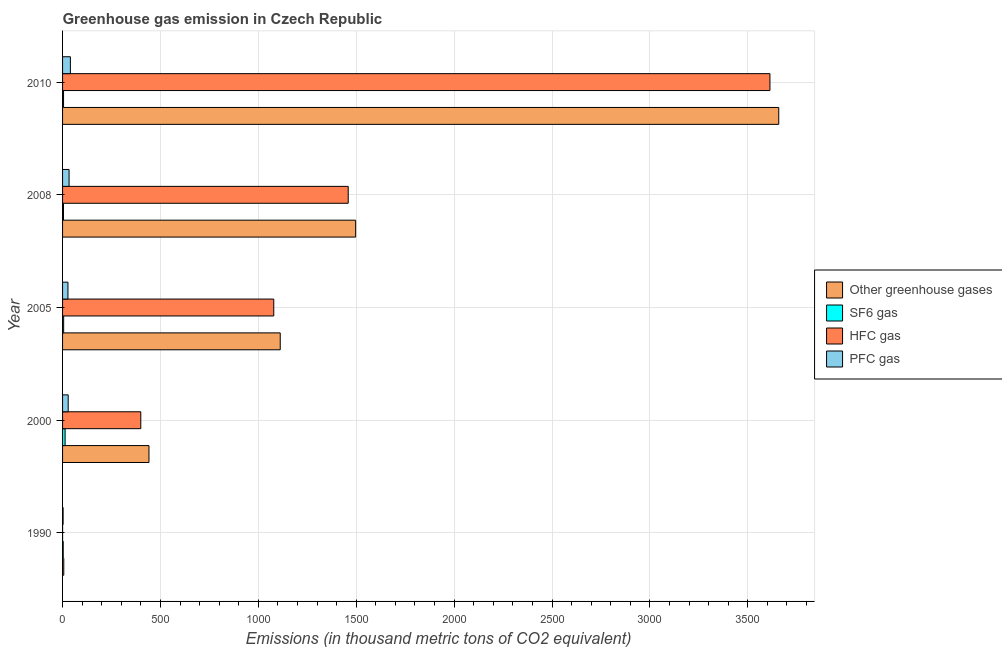How many different coloured bars are there?
Your response must be concise. 4. How many groups of bars are there?
Offer a terse response. 5. Are the number of bars per tick equal to the number of legend labels?
Ensure brevity in your answer.  Yes. How many bars are there on the 4th tick from the top?
Your answer should be compact. 4. What is the label of the 5th group of bars from the top?
Keep it short and to the point. 1990. In how many cases, is the number of bars for a given year not equal to the number of legend labels?
Provide a short and direct response. 0. What is the emission of hfc gas in 2005?
Provide a succinct answer. 1078.7. Across all years, what is the maximum emission of hfc gas?
Your answer should be very brief. 3613. Across all years, what is the minimum emission of pfc gas?
Your response must be concise. 2.8. In which year was the emission of sf6 gas maximum?
Ensure brevity in your answer.  2000. What is the total emission of hfc gas in the graph?
Provide a short and direct response. 6550.3. What is the difference between the emission of greenhouse gases in 2008 and that in 2010?
Ensure brevity in your answer.  -2161. What is the difference between the emission of greenhouse gases in 1990 and the emission of hfc gas in 2000?
Provide a short and direct response. -393.3. What is the average emission of hfc gas per year?
Offer a very short reply. 1310.06. In the year 2008, what is the difference between the emission of greenhouse gases and emission of sf6 gas?
Provide a succinct answer. 1492.3. What is the ratio of the emission of greenhouse gases in 1990 to that in 2005?
Offer a very short reply. 0.01. Is the emission of hfc gas in 1990 less than that in 2010?
Ensure brevity in your answer.  Yes. Is the difference between the emission of sf6 gas in 1990 and 2010 greater than the difference between the emission of pfc gas in 1990 and 2010?
Your answer should be very brief. Yes. What is the difference between the highest and the second highest emission of greenhouse gases?
Keep it short and to the point. 2161. What is the difference between the highest and the lowest emission of pfc gas?
Offer a terse response. 37.2. In how many years, is the emission of greenhouse gases greater than the average emission of greenhouse gases taken over all years?
Keep it short and to the point. 2. What does the 4th bar from the top in 1990 represents?
Offer a very short reply. Other greenhouse gases. What does the 4th bar from the bottom in 2005 represents?
Give a very brief answer. PFC gas. Is it the case that in every year, the sum of the emission of greenhouse gases and emission of sf6 gas is greater than the emission of hfc gas?
Provide a short and direct response. Yes. Are the values on the major ticks of X-axis written in scientific E-notation?
Your answer should be very brief. No. Does the graph contain any zero values?
Give a very brief answer. No. Does the graph contain grids?
Offer a very short reply. Yes. Where does the legend appear in the graph?
Keep it short and to the point. Center right. How many legend labels are there?
Provide a short and direct response. 4. What is the title of the graph?
Ensure brevity in your answer.  Greenhouse gas emission in Czech Republic. What is the label or title of the X-axis?
Offer a terse response. Emissions (in thousand metric tons of CO2 equivalent). What is the Emissions (in thousand metric tons of CO2 equivalent) of SF6 gas in 1990?
Ensure brevity in your answer.  3.3. What is the Emissions (in thousand metric tons of CO2 equivalent) of HFC gas in 1990?
Provide a succinct answer. 0.1. What is the Emissions (in thousand metric tons of CO2 equivalent) in PFC gas in 1990?
Provide a short and direct response. 2.8. What is the Emissions (in thousand metric tons of CO2 equivalent) in Other greenhouse gases in 2000?
Provide a short and direct response. 441.3. What is the Emissions (in thousand metric tons of CO2 equivalent) in HFC gas in 2000?
Offer a terse response. 399.5. What is the Emissions (in thousand metric tons of CO2 equivalent) in PFC gas in 2000?
Give a very brief answer. 28.8. What is the Emissions (in thousand metric tons of CO2 equivalent) of Other greenhouse gases in 2005?
Make the answer very short. 1111.8. What is the Emissions (in thousand metric tons of CO2 equivalent) of HFC gas in 2005?
Offer a terse response. 1078.7. What is the Emissions (in thousand metric tons of CO2 equivalent) in Other greenhouse gases in 2008?
Provide a short and direct response. 1497. What is the Emissions (in thousand metric tons of CO2 equivalent) in SF6 gas in 2008?
Provide a short and direct response. 4.7. What is the Emissions (in thousand metric tons of CO2 equivalent) in HFC gas in 2008?
Your answer should be very brief. 1459. What is the Emissions (in thousand metric tons of CO2 equivalent) of PFC gas in 2008?
Your response must be concise. 33.3. What is the Emissions (in thousand metric tons of CO2 equivalent) of Other greenhouse gases in 2010?
Your answer should be very brief. 3658. What is the Emissions (in thousand metric tons of CO2 equivalent) in SF6 gas in 2010?
Offer a terse response. 5. What is the Emissions (in thousand metric tons of CO2 equivalent) of HFC gas in 2010?
Your response must be concise. 3613. What is the Emissions (in thousand metric tons of CO2 equivalent) in PFC gas in 2010?
Offer a very short reply. 40. Across all years, what is the maximum Emissions (in thousand metric tons of CO2 equivalent) in Other greenhouse gases?
Ensure brevity in your answer.  3658. Across all years, what is the maximum Emissions (in thousand metric tons of CO2 equivalent) of HFC gas?
Your answer should be very brief. 3613. Across all years, what is the minimum Emissions (in thousand metric tons of CO2 equivalent) of Other greenhouse gases?
Offer a terse response. 6.2. Across all years, what is the minimum Emissions (in thousand metric tons of CO2 equivalent) in PFC gas?
Give a very brief answer. 2.8. What is the total Emissions (in thousand metric tons of CO2 equivalent) of Other greenhouse gases in the graph?
Provide a succinct answer. 6714.3. What is the total Emissions (in thousand metric tons of CO2 equivalent) of SF6 gas in the graph?
Your response must be concise. 31.6. What is the total Emissions (in thousand metric tons of CO2 equivalent) of HFC gas in the graph?
Ensure brevity in your answer.  6550.3. What is the total Emissions (in thousand metric tons of CO2 equivalent) of PFC gas in the graph?
Give a very brief answer. 132.4. What is the difference between the Emissions (in thousand metric tons of CO2 equivalent) of Other greenhouse gases in 1990 and that in 2000?
Offer a terse response. -435.1. What is the difference between the Emissions (in thousand metric tons of CO2 equivalent) in HFC gas in 1990 and that in 2000?
Offer a very short reply. -399.4. What is the difference between the Emissions (in thousand metric tons of CO2 equivalent) in PFC gas in 1990 and that in 2000?
Provide a succinct answer. -26. What is the difference between the Emissions (in thousand metric tons of CO2 equivalent) of Other greenhouse gases in 1990 and that in 2005?
Give a very brief answer. -1105.6. What is the difference between the Emissions (in thousand metric tons of CO2 equivalent) of SF6 gas in 1990 and that in 2005?
Give a very brief answer. -2.3. What is the difference between the Emissions (in thousand metric tons of CO2 equivalent) of HFC gas in 1990 and that in 2005?
Give a very brief answer. -1078.6. What is the difference between the Emissions (in thousand metric tons of CO2 equivalent) in PFC gas in 1990 and that in 2005?
Provide a short and direct response. -24.7. What is the difference between the Emissions (in thousand metric tons of CO2 equivalent) in Other greenhouse gases in 1990 and that in 2008?
Your answer should be very brief. -1490.8. What is the difference between the Emissions (in thousand metric tons of CO2 equivalent) of HFC gas in 1990 and that in 2008?
Provide a short and direct response. -1458.9. What is the difference between the Emissions (in thousand metric tons of CO2 equivalent) of PFC gas in 1990 and that in 2008?
Your response must be concise. -30.5. What is the difference between the Emissions (in thousand metric tons of CO2 equivalent) of Other greenhouse gases in 1990 and that in 2010?
Ensure brevity in your answer.  -3651.8. What is the difference between the Emissions (in thousand metric tons of CO2 equivalent) in SF6 gas in 1990 and that in 2010?
Make the answer very short. -1.7. What is the difference between the Emissions (in thousand metric tons of CO2 equivalent) in HFC gas in 1990 and that in 2010?
Ensure brevity in your answer.  -3612.9. What is the difference between the Emissions (in thousand metric tons of CO2 equivalent) of PFC gas in 1990 and that in 2010?
Provide a succinct answer. -37.2. What is the difference between the Emissions (in thousand metric tons of CO2 equivalent) in Other greenhouse gases in 2000 and that in 2005?
Give a very brief answer. -670.5. What is the difference between the Emissions (in thousand metric tons of CO2 equivalent) in SF6 gas in 2000 and that in 2005?
Your answer should be very brief. 7.4. What is the difference between the Emissions (in thousand metric tons of CO2 equivalent) of HFC gas in 2000 and that in 2005?
Keep it short and to the point. -679.2. What is the difference between the Emissions (in thousand metric tons of CO2 equivalent) in PFC gas in 2000 and that in 2005?
Your response must be concise. 1.3. What is the difference between the Emissions (in thousand metric tons of CO2 equivalent) in Other greenhouse gases in 2000 and that in 2008?
Provide a succinct answer. -1055.7. What is the difference between the Emissions (in thousand metric tons of CO2 equivalent) in HFC gas in 2000 and that in 2008?
Provide a succinct answer. -1059.5. What is the difference between the Emissions (in thousand metric tons of CO2 equivalent) of PFC gas in 2000 and that in 2008?
Offer a terse response. -4.5. What is the difference between the Emissions (in thousand metric tons of CO2 equivalent) of Other greenhouse gases in 2000 and that in 2010?
Make the answer very short. -3216.7. What is the difference between the Emissions (in thousand metric tons of CO2 equivalent) of SF6 gas in 2000 and that in 2010?
Your response must be concise. 8. What is the difference between the Emissions (in thousand metric tons of CO2 equivalent) of HFC gas in 2000 and that in 2010?
Offer a very short reply. -3213.5. What is the difference between the Emissions (in thousand metric tons of CO2 equivalent) in PFC gas in 2000 and that in 2010?
Make the answer very short. -11.2. What is the difference between the Emissions (in thousand metric tons of CO2 equivalent) of Other greenhouse gases in 2005 and that in 2008?
Keep it short and to the point. -385.2. What is the difference between the Emissions (in thousand metric tons of CO2 equivalent) in HFC gas in 2005 and that in 2008?
Provide a short and direct response. -380.3. What is the difference between the Emissions (in thousand metric tons of CO2 equivalent) of PFC gas in 2005 and that in 2008?
Ensure brevity in your answer.  -5.8. What is the difference between the Emissions (in thousand metric tons of CO2 equivalent) in Other greenhouse gases in 2005 and that in 2010?
Your response must be concise. -2546.2. What is the difference between the Emissions (in thousand metric tons of CO2 equivalent) of HFC gas in 2005 and that in 2010?
Make the answer very short. -2534.3. What is the difference between the Emissions (in thousand metric tons of CO2 equivalent) in Other greenhouse gases in 2008 and that in 2010?
Give a very brief answer. -2161. What is the difference between the Emissions (in thousand metric tons of CO2 equivalent) in HFC gas in 2008 and that in 2010?
Your answer should be compact. -2154. What is the difference between the Emissions (in thousand metric tons of CO2 equivalent) in PFC gas in 2008 and that in 2010?
Keep it short and to the point. -6.7. What is the difference between the Emissions (in thousand metric tons of CO2 equivalent) in Other greenhouse gases in 1990 and the Emissions (in thousand metric tons of CO2 equivalent) in HFC gas in 2000?
Give a very brief answer. -393.3. What is the difference between the Emissions (in thousand metric tons of CO2 equivalent) in Other greenhouse gases in 1990 and the Emissions (in thousand metric tons of CO2 equivalent) in PFC gas in 2000?
Give a very brief answer. -22.6. What is the difference between the Emissions (in thousand metric tons of CO2 equivalent) in SF6 gas in 1990 and the Emissions (in thousand metric tons of CO2 equivalent) in HFC gas in 2000?
Your answer should be compact. -396.2. What is the difference between the Emissions (in thousand metric tons of CO2 equivalent) in SF6 gas in 1990 and the Emissions (in thousand metric tons of CO2 equivalent) in PFC gas in 2000?
Keep it short and to the point. -25.5. What is the difference between the Emissions (in thousand metric tons of CO2 equivalent) in HFC gas in 1990 and the Emissions (in thousand metric tons of CO2 equivalent) in PFC gas in 2000?
Your answer should be compact. -28.7. What is the difference between the Emissions (in thousand metric tons of CO2 equivalent) in Other greenhouse gases in 1990 and the Emissions (in thousand metric tons of CO2 equivalent) in SF6 gas in 2005?
Offer a terse response. 0.6. What is the difference between the Emissions (in thousand metric tons of CO2 equivalent) of Other greenhouse gases in 1990 and the Emissions (in thousand metric tons of CO2 equivalent) of HFC gas in 2005?
Offer a very short reply. -1072.5. What is the difference between the Emissions (in thousand metric tons of CO2 equivalent) in Other greenhouse gases in 1990 and the Emissions (in thousand metric tons of CO2 equivalent) in PFC gas in 2005?
Your answer should be very brief. -21.3. What is the difference between the Emissions (in thousand metric tons of CO2 equivalent) in SF6 gas in 1990 and the Emissions (in thousand metric tons of CO2 equivalent) in HFC gas in 2005?
Ensure brevity in your answer.  -1075.4. What is the difference between the Emissions (in thousand metric tons of CO2 equivalent) of SF6 gas in 1990 and the Emissions (in thousand metric tons of CO2 equivalent) of PFC gas in 2005?
Keep it short and to the point. -24.2. What is the difference between the Emissions (in thousand metric tons of CO2 equivalent) in HFC gas in 1990 and the Emissions (in thousand metric tons of CO2 equivalent) in PFC gas in 2005?
Give a very brief answer. -27.4. What is the difference between the Emissions (in thousand metric tons of CO2 equivalent) of Other greenhouse gases in 1990 and the Emissions (in thousand metric tons of CO2 equivalent) of HFC gas in 2008?
Keep it short and to the point. -1452.8. What is the difference between the Emissions (in thousand metric tons of CO2 equivalent) in Other greenhouse gases in 1990 and the Emissions (in thousand metric tons of CO2 equivalent) in PFC gas in 2008?
Keep it short and to the point. -27.1. What is the difference between the Emissions (in thousand metric tons of CO2 equivalent) of SF6 gas in 1990 and the Emissions (in thousand metric tons of CO2 equivalent) of HFC gas in 2008?
Offer a very short reply. -1455.7. What is the difference between the Emissions (in thousand metric tons of CO2 equivalent) in HFC gas in 1990 and the Emissions (in thousand metric tons of CO2 equivalent) in PFC gas in 2008?
Give a very brief answer. -33.2. What is the difference between the Emissions (in thousand metric tons of CO2 equivalent) in Other greenhouse gases in 1990 and the Emissions (in thousand metric tons of CO2 equivalent) in SF6 gas in 2010?
Your response must be concise. 1.2. What is the difference between the Emissions (in thousand metric tons of CO2 equivalent) in Other greenhouse gases in 1990 and the Emissions (in thousand metric tons of CO2 equivalent) in HFC gas in 2010?
Provide a short and direct response. -3606.8. What is the difference between the Emissions (in thousand metric tons of CO2 equivalent) of Other greenhouse gases in 1990 and the Emissions (in thousand metric tons of CO2 equivalent) of PFC gas in 2010?
Offer a very short reply. -33.8. What is the difference between the Emissions (in thousand metric tons of CO2 equivalent) in SF6 gas in 1990 and the Emissions (in thousand metric tons of CO2 equivalent) in HFC gas in 2010?
Your answer should be compact. -3609.7. What is the difference between the Emissions (in thousand metric tons of CO2 equivalent) of SF6 gas in 1990 and the Emissions (in thousand metric tons of CO2 equivalent) of PFC gas in 2010?
Your response must be concise. -36.7. What is the difference between the Emissions (in thousand metric tons of CO2 equivalent) in HFC gas in 1990 and the Emissions (in thousand metric tons of CO2 equivalent) in PFC gas in 2010?
Give a very brief answer. -39.9. What is the difference between the Emissions (in thousand metric tons of CO2 equivalent) of Other greenhouse gases in 2000 and the Emissions (in thousand metric tons of CO2 equivalent) of SF6 gas in 2005?
Give a very brief answer. 435.7. What is the difference between the Emissions (in thousand metric tons of CO2 equivalent) of Other greenhouse gases in 2000 and the Emissions (in thousand metric tons of CO2 equivalent) of HFC gas in 2005?
Provide a succinct answer. -637.4. What is the difference between the Emissions (in thousand metric tons of CO2 equivalent) of Other greenhouse gases in 2000 and the Emissions (in thousand metric tons of CO2 equivalent) of PFC gas in 2005?
Your answer should be very brief. 413.8. What is the difference between the Emissions (in thousand metric tons of CO2 equivalent) in SF6 gas in 2000 and the Emissions (in thousand metric tons of CO2 equivalent) in HFC gas in 2005?
Give a very brief answer. -1065.7. What is the difference between the Emissions (in thousand metric tons of CO2 equivalent) in SF6 gas in 2000 and the Emissions (in thousand metric tons of CO2 equivalent) in PFC gas in 2005?
Offer a very short reply. -14.5. What is the difference between the Emissions (in thousand metric tons of CO2 equivalent) of HFC gas in 2000 and the Emissions (in thousand metric tons of CO2 equivalent) of PFC gas in 2005?
Offer a very short reply. 372. What is the difference between the Emissions (in thousand metric tons of CO2 equivalent) of Other greenhouse gases in 2000 and the Emissions (in thousand metric tons of CO2 equivalent) of SF6 gas in 2008?
Provide a short and direct response. 436.6. What is the difference between the Emissions (in thousand metric tons of CO2 equivalent) of Other greenhouse gases in 2000 and the Emissions (in thousand metric tons of CO2 equivalent) of HFC gas in 2008?
Provide a short and direct response. -1017.7. What is the difference between the Emissions (in thousand metric tons of CO2 equivalent) of Other greenhouse gases in 2000 and the Emissions (in thousand metric tons of CO2 equivalent) of PFC gas in 2008?
Ensure brevity in your answer.  408. What is the difference between the Emissions (in thousand metric tons of CO2 equivalent) of SF6 gas in 2000 and the Emissions (in thousand metric tons of CO2 equivalent) of HFC gas in 2008?
Provide a short and direct response. -1446. What is the difference between the Emissions (in thousand metric tons of CO2 equivalent) in SF6 gas in 2000 and the Emissions (in thousand metric tons of CO2 equivalent) in PFC gas in 2008?
Ensure brevity in your answer.  -20.3. What is the difference between the Emissions (in thousand metric tons of CO2 equivalent) in HFC gas in 2000 and the Emissions (in thousand metric tons of CO2 equivalent) in PFC gas in 2008?
Offer a very short reply. 366.2. What is the difference between the Emissions (in thousand metric tons of CO2 equivalent) of Other greenhouse gases in 2000 and the Emissions (in thousand metric tons of CO2 equivalent) of SF6 gas in 2010?
Provide a succinct answer. 436.3. What is the difference between the Emissions (in thousand metric tons of CO2 equivalent) of Other greenhouse gases in 2000 and the Emissions (in thousand metric tons of CO2 equivalent) of HFC gas in 2010?
Keep it short and to the point. -3171.7. What is the difference between the Emissions (in thousand metric tons of CO2 equivalent) of Other greenhouse gases in 2000 and the Emissions (in thousand metric tons of CO2 equivalent) of PFC gas in 2010?
Make the answer very short. 401.3. What is the difference between the Emissions (in thousand metric tons of CO2 equivalent) of SF6 gas in 2000 and the Emissions (in thousand metric tons of CO2 equivalent) of HFC gas in 2010?
Offer a very short reply. -3600. What is the difference between the Emissions (in thousand metric tons of CO2 equivalent) in SF6 gas in 2000 and the Emissions (in thousand metric tons of CO2 equivalent) in PFC gas in 2010?
Provide a short and direct response. -27. What is the difference between the Emissions (in thousand metric tons of CO2 equivalent) of HFC gas in 2000 and the Emissions (in thousand metric tons of CO2 equivalent) of PFC gas in 2010?
Offer a terse response. 359.5. What is the difference between the Emissions (in thousand metric tons of CO2 equivalent) of Other greenhouse gases in 2005 and the Emissions (in thousand metric tons of CO2 equivalent) of SF6 gas in 2008?
Ensure brevity in your answer.  1107.1. What is the difference between the Emissions (in thousand metric tons of CO2 equivalent) in Other greenhouse gases in 2005 and the Emissions (in thousand metric tons of CO2 equivalent) in HFC gas in 2008?
Your response must be concise. -347.2. What is the difference between the Emissions (in thousand metric tons of CO2 equivalent) of Other greenhouse gases in 2005 and the Emissions (in thousand metric tons of CO2 equivalent) of PFC gas in 2008?
Keep it short and to the point. 1078.5. What is the difference between the Emissions (in thousand metric tons of CO2 equivalent) in SF6 gas in 2005 and the Emissions (in thousand metric tons of CO2 equivalent) in HFC gas in 2008?
Make the answer very short. -1453.4. What is the difference between the Emissions (in thousand metric tons of CO2 equivalent) of SF6 gas in 2005 and the Emissions (in thousand metric tons of CO2 equivalent) of PFC gas in 2008?
Keep it short and to the point. -27.7. What is the difference between the Emissions (in thousand metric tons of CO2 equivalent) in HFC gas in 2005 and the Emissions (in thousand metric tons of CO2 equivalent) in PFC gas in 2008?
Give a very brief answer. 1045.4. What is the difference between the Emissions (in thousand metric tons of CO2 equivalent) of Other greenhouse gases in 2005 and the Emissions (in thousand metric tons of CO2 equivalent) of SF6 gas in 2010?
Your response must be concise. 1106.8. What is the difference between the Emissions (in thousand metric tons of CO2 equivalent) in Other greenhouse gases in 2005 and the Emissions (in thousand metric tons of CO2 equivalent) in HFC gas in 2010?
Your answer should be compact. -2501.2. What is the difference between the Emissions (in thousand metric tons of CO2 equivalent) of Other greenhouse gases in 2005 and the Emissions (in thousand metric tons of CO2 equivalent) of PFC gas in 2010?
Give a very brief answer. 1071.8. What is the difference between the Emissions (in thousand metric tons of CO2 equivalent) in SF6 gas in 2005 and the Emissions (in thousand metric tons of CO2 equivalent) in HFC gas in 2010?
Provide a succinct answer. -3607.4. What is the difference between the Emissions (in thousand metric tons of CO2 equivalent) of SF6 gas in 2005 and the Emissions (in thousand metric tons of CO2 equivalent) of PFC gas in 2010?
Your response must be concise. -34.4. What is the difference between the Emissions (in thousand metric tons of CO2 equivalent) of HFC gas in 2005 and the Emissions (in thousand metric tons of CO2 equivalent) of PFC gas in 2010?
Keep it short and to the point. 1038.7. What is the difference between the Emissions (in thousand metric tons of CO2 equivalent) of Other greenhouse gases in 2008 and the Emissions (in thousand metric tons of CO2 equivalent) of SF6 gas in 2010?
Ensure brevity in your answer.  1492. What is the difference between the Emissions (in thousand metric tons of CO2 equivalent) of Other greenhouse gases in 2008 and the Emissions (in thousand metric tons of CO2 equivalent) of HFC gas in 2010?
Offer a very short reply. -2116. What is the difference between the Emissions (in thousand metric tons of CO2 equivalent) of Other greenhouse gases in 2008 and the Emissions (in thousand metric tons of CO2 equivalent) of PFC gas in 2010?
Keep it short and to the point. 1457. What is the difference between the Emissions (in thousand metric tons of CO2 equivalent) in SF6 gas in 2008 and the Emissions (in thousand metric tons of CO2 equivalent) in HFC gas in 2010?
Make the answer very short. -3608.3. What is the difference between the Emissions (in thousand metric tons of CO2 equivalent) in SF6 gas in 2008 and the Emissions (in thousand metric tons of CO2 equivalent) in PFC gas in 2010?
Ensure brevity in your answer.  -35.3. What is the difference between the Emissions (in thousand metric tons of CO2 equivalent) of HFC gas in 2008 and the Emissions (in thousand metric tons of CO2 equivalent) of PFC gas in 2010?
Give a very brief answer. 1419. What is the average Emissions (in thousand metric tons of CO2 equivalent) in Other greenhouse gases per year?
Make the answer very short. 1342.86. What is the average Emissions (in thousand metric tons of CO2 equivalent) of SF6 gas per year?
Your answer should be very brief. 6.32. What is the average Emissions (in thousand metric tons of CO2 equivalent) of HFC gas per year?
Offer a terse response. 1310.06. What is the average Emissions (in thousand metric tons of CO2 equivalent) in PFC gas per year?
Ensure brevity in your answer.  26.48. In the year 1990, what is the difference between the Emissions (in thousand metric tons of CO2 equivalent) of Other greenhouse gases and Emissions (in thousand metric tons of CO2 equivalent) of SF6 gas?
Your answer should be very brief. 2.9. In the year 1990, what is the difference between the Emissions (in thousand metric tons of CO2 equivalent) of Other greenhouse gases and Emissions (in thousand metric tons of CO2 equivalent) of HFC gas?
Offer a very short reply. 6.1. In the year 1990, what is the difference between the Emissions (in thousand metric tons of CO2 equivalent) in SF6 gas and Emissions (in thousand metric tons of CO2 equivalent) in HFC gas?
Your answer should be very brief. 3.2. In the year 1990, what is the difference between the Emissions (in thousand metric tons of CO2 equivalent) of HFC gas and Emissions (in thousand metric tons of CO2 equivalent) of PFC gas?
Provide a succinct answer. -2.7. In the year 2000, what is the difference between the Emissions (in thousand metric tons of CO2 equivalent) of Other greenhouse gases and Emissions (in thousand metric tons of CO2 equivalent) of SF6 gas?
Keep it short and to the point. 428.3. In the year 2000, what is the difference between the Emissions (in thousand metric tons of CO2 equivalent) in Other greenhouse gases and Emissions (in thousand metric tons of CO2 equivalent) in HFC gas?
Keep it short and to the point. 41.8. In the year 2000, what is the difference between the Emissions (in thousand metric tons of CO2 equivalent) in Other greenhouse gases and Emissions (in thousand metric tons of CO2 equivalent) in PFC gas?
Make the answer very short. 412.5. In the year 2000, what is the difference between the Emissions (in thousand metric tons of CO2 equivalent) of SF6 gas and Emissions (in thousand metric tons of CO2 equivalent) of HFC gas?
Give a very brief answer. -386.5. In the year 2000, what is the difference between the Emissions (in thousand metric tons of CO2 equivalent) of SF6 gas and Emissions (in thousand metric tons of CO2 equivalent) of PFC gas?
Your response must be concise. -15.8. In the year 2000, what is the difference between the Emissions (in thousand metric tons of CO2 equivalent) in HFC gas and Emissions (in thousand metric tons of CO2 equivalent) in PFC gas?
Offer a very short reply. 370.7. In the year 2005, what is the difference between the Emissions (in thousand metric tons of CO2 equivalent) in Other greenhouse gases and Emissions (in thousand metric tons of CO2 equivalent) in SF6 gas?
Your response must be concise. 1106.2. In the year 2005, what is the difference between the Emissions (in thousand metric tons of CO2 equivalent) in Other greenhouse gases and Emissions (in thousand metric tons of CO2 equivalent) in HFC gas?
Ensure brevity in your answer.  33.1. In the year 2005, what is the difference between the Emissions (in thousand metric tons of CO2 equivalent) of Other greenhouse gases and Emissions (in thousand metric tons of CO2 equivalent) of PFC gas?
Your answer should be compact. 1084.3. In the year 2005, what is the difference between the Emissions (in thousand metric tons of CO2 equivalent) in SF6 gas and Emissions (in thousand metric tons of CO2 equivalent) in HFC gas?
Your answer should be compact. -1073.1. In the year 2005, what is the difference between the Emissions (in thousand metric tons of CO2 equivalent) in SF6 gas and Emissions (in thousand metric tons of CO2 equivalent) in PFC gas?
Ensure brevity in your answer.  -21.9. In the year 2005, what is the difference between the Emissions (in thousand metric tons of CO2 equivalent) in HFC gas and Emissions (in thousand metric tons of CO2 equivalent) in PFC gas?
Provide a short and direct response. 1051.2. In the year 2008, what is the difference between the Emissions (in thousand metric tons of CO2 equivalent) of Other greenhouse gases and Emissions (in thousand metric tons of CO2 equivalent) of SF6 gas?
Provide a succinct answer. 1492.3. In the year 2008, what is the difference between the Emissions (in thousand metric tons of CO2 equivalent) in Other greenhouse gases and Emissions (in thousand metric tons of CO2 equivalent) in PFC gas?
Provide a short and direct response. 1463.7. In the year 2008, what is the difference between the Emissions (in thousand metric tons of CO2 equivalent) in SF6 gas and Emissions (in thousand metric tons of CO2 equivalent) in HFC gas?
Keep it short and to the point. -1454.3. In the year 2008, what is the difference between the Emissions (in thousand metric tons of CO2 equivalent) of SF6 gas and Emissions (in thousand metric tons of CO2 equivalent) of PFC gas?
Your response must be concise. -28.6. In the year 2008, what is the difference between the Emissions (in thousand metric tons of CO2 equivalent) in HFC gas and Emissions (in thousand metric tons of CO2 equivalent) in PFC gas?
Your answer should be very brief. 1425.7. In the year 2010, what is the difference between the Emissions (in thousand metric tons of CO2 equivalent) in Other greenhouse gases and Emissions (in thousand metric tons of CO2 equivalent) in SF6 gas?
Your answer should be very brief. 3653. In the year 2010, what is the difference between the Emissions (in thousand metric tons of CO2 equivalent) in Other greenhouse gases and Emissions (in thousand metric tons of CO2 equivalent) in HFC gas?
Give a very brief answer. 45. In the year 2010, what is the difference between the Emissions (in thousand metric tons of CO2 equivalent) in Other greenhouse gases and Emissions (in thousand metric tons of CO2 equivalent) in PFC gas?
Provide a short and direct response. 3618. In the year 2010, what is the difference between the Emissions (in thousand metric tons of CO2 equivalent) of SF6 gas and Emissions (in thousand metric tons of CO2 equivalent) of HFC gas?
Keep it short and to the point. -3608. In the year 2010, what is the difference between the Emissions (in thousand metric tons of CO2 equivalent) of SF6 gas and Emissions (in thousand metric tons of CO2 equivalent) of PFC gas?
Keep it short and to the point. -35. In the year 2010, what is the difference between the Emissions (in thousand metric tons of CO2 equivalent) in HFC gas and Emissions (in thousand metric tons of CO2 equivalent) in PFC gas?
Your answer should be compact. 3573. What is the ratio of the Emissions (in thousand metric tons of CO2 equivalent) of Other greenhouse gases in 1990 to that in 2000?
Offer a terse response. 0.01. What is the ratio of the Emissions (in thousand metric tons of CO2 equivalent) in SF6 gas in 1990 to that in 2000?
Make the answer very short. 0.25. What is the ratio of the Emissions (in thousand metric tons of CO2 equivalent) in PFC gas in 1990 to that in 2000?
Offer a terse response. 0.1. What is the ratio of the Emissions (in thousand metric tons of CO2 equivalent) of Other greenhouse gases in 1990 to that in 2005?
Your answer should be compact. 0.01. What is the ratio of the Emissions (in thousand metric tons of CO2 equivalent) of SF6 gas in 1990 to that in 2005?
Provide a succinct answer. 0.59. What is the ratio of the Emissions (in thousand metric tons of CO2 equivalent) in PFC gas in 1990 to that in 2005?
Provide a short and direct response. 0.1. What is the ratio of the Emissions (in thousand metric tons of CO2 equivalent) in Other greenhouse gases in 1990 to that in 2008?
Provide a short and direct response. 0. What is the ratio of the Emissions (in thousand metric tons of CO2 equivalent) of SF6 gas in 1990 to that in 2008?
Keep it short and to the point. 0.7. What is the ratio of the Emissions (in thousand metric tons of CO2 equivalent) of HFC gas in 1990 to that in 2008?
Provide a short and direct response. 0. What is the ratio of the Emissions (in thousand metric tons of CO2 equivalent) in PFC gas in 1990 to that in 2008?
Keep it short and to the point. 0.08. What is the ratio of the Emissions (in thousand metric tons of CO2 equivalent) of Other greenhouse gases in 1990 to that in 2010?
Your response must be concise. 0. What is the ratio of the Emissions (in thousand metric tons of CO2 equivalent) in SF6 gas in 1990 to that in 2010?
Ensure brevity in your answer.  0.66. What is the ratio of the Emissions (in thousand metric tons of CO2 equivalent) of HFC gas in 1990 to that in 2010?
Your answer should be very brief. 0. What is the ratio of the Emissions (in thousand metric tons of CO2 equivalent) of PFC gas in 1990 to that in 2010?
Ensure brevity in your answer.  0.07. What is the ratio of the Emissions (in thousand metric tons of CO2 equivalent) of Other greenhouse gases in 2000 to that in 2005?
Make the answer very short. 0.4. What is the ratio of the Emissions (in thousand metric tons of CO2 equivalent) of SF6 gas in 2000 to that in 2005?
Offer a terse response. 2.32. What is the ratio of the Emissions (in thousand metric tons of CO2 equivalent) of HFC gas in 2000 to that in 2005?
Your answer should be very brief. 0.37. What is the ratio of the Emissions (in thousand metric tons of CO2 equivalent) in PFC gas in 2000 to that in 2005?
Your answer should be very brief. 1.05. What is the ratio of the Emissions (in thousand metric tons of CO2 equivalent) of Other greenhouse gases in 2000 to that in 2008?
Give a very brief answer. 0.29. What is the ratio of the Emissions (in thousand metric tons of CO2 equivalent) of SF6 gas in 2000 to that in 2008?
Make the answer very short. 2.77. What is the ratio of the Emissions (in thousand metric tons of CO2 equivalent) of HFC gas in 2000 to that in 2008?
Provide a succinct answer. 0.27. What is the ratio of the Emissions (in thousand metric tons of CO2 equivalent) of PFC gas in 2000 to that in 2008?
Your response must be concise. 0.86. What is the ratio of the Emissions (in thousand metric tons of CO2 equivalent) in Other greenhouse gases in 2000 to that in 2010?
Your answer should be compact. 0.12. What is the ratio of the Emissions (in thousand metric tons of CO2 equivalent) in SF6 gas in 2000 to that in 2010?
Ensure brevity in your answer.  2.6. What is the ratio of the Emissions (in thousand metric tons of CO2 equivalent) in HFC gas in 2000 to that in 2010?
Provide a succinct answer. 0.11. What is the ratio of the Emissions (in thousand metric tons of CO2 equivalent) of PFC gas in 2000 to that in 2010?
Make the answer very short. 0.72. What is the ratio of the Emissions (in thousand metric tons of CO2 equivalent) in Other greenhouse gases in 2005 to that in 2008?
Offer a very short reply. 0.74. What is the ratio of the Emissions (in thousand metric tons of CO2 equivalent) of SF6 gas in 2005 to that in 2008?
Provide a short and direct response. 1.19. What is the ratio of the Emissions (in thousand metric tons of CO2 equivalent) in HFC gas in 2005 to that in 2008?
Ensure brevity in your answer.  0.74. What is the ratio of the Emissions (in thousand metric tons of CO2 equivalent) in PFC gas in 2005 to that in 2008?
Provide a succinct answer. 0.83. What is the ratio of the Emissions (in thousand metric tons of CO2 equivalent) of Other greenhouse gases in 2005 to that in 2010?
Offer a very short reply. 0.3. What is the ratio of the Emissions (in thousand metric tons of CO2 equivalent) of SF6 gas in 2005 to that in 2010?
Provide a succinct answer. 1.12. What is the ratio of the Emissions (in thousand metric tons of CO2 equivalent) of HFC gas in 2005 to that in 2010?
Your answer should be compact. 0.3. What is the ratio of the Emissions (in thousand metric tons of CO2 equivalent) of PFC gas in 2005 to that in 2010?
Ensure brevity in your answer.  0.69. What is the ratio of the Emissions (in thousand metric tons of CO2 equivalent) of Other greenhouse gases in 2008 to that in 2010?
Offer a very short reply. 0.41. What is the ratio of the Emissions (in thousand metric tons of CO2 equivalent) of HFC gas in 2008 to that in 2010?
Offer a terse response. 0.4. What is the ratio of the Emissions (in thousand metric tons of CO2 equivalent) in PFC gas in 2008 to that in 2010?
Offer a very short reply. 0.83. What is the difference between the highest and the second highest Emissions (in thousand metric tons of CO2 equivalent) of Other greenhouse gases?
Offer a very short reply. 2161. What is the difference between the highest and the second highest Emissions (in thousand metric tons of CO2 equivalent) of HFC gas?
Your answer should be very brief. 2154. What is the difference between the highest and the second highest Emissions (in thousand metric tons of CO2 equivalent) in PFC gas?
Offer a very short reply. 6.7. What is the difference between the highest and the lowest Emissions (in thousand metric tons of CO2 equivalent) of Other greenhouse gases?
Provide a succinct answer. 3651.8. What is the difference between the highest and the lowest Emissions (in thousand metric tons of CO2 equivalent) of SF6 gas?
Offer a very short reply. 9.7. What is the difference between the highest and the lowest Emissions (in thousand metric tons of CO2 equivalent) of HFC gas?
Keep it short and to the point. 3612.9. What is the difference between the highest and the lowest Emissions (in thousand metric tons of CO2 equivalent) in PFC gas?
Provide a short and direct response. 37.2. 